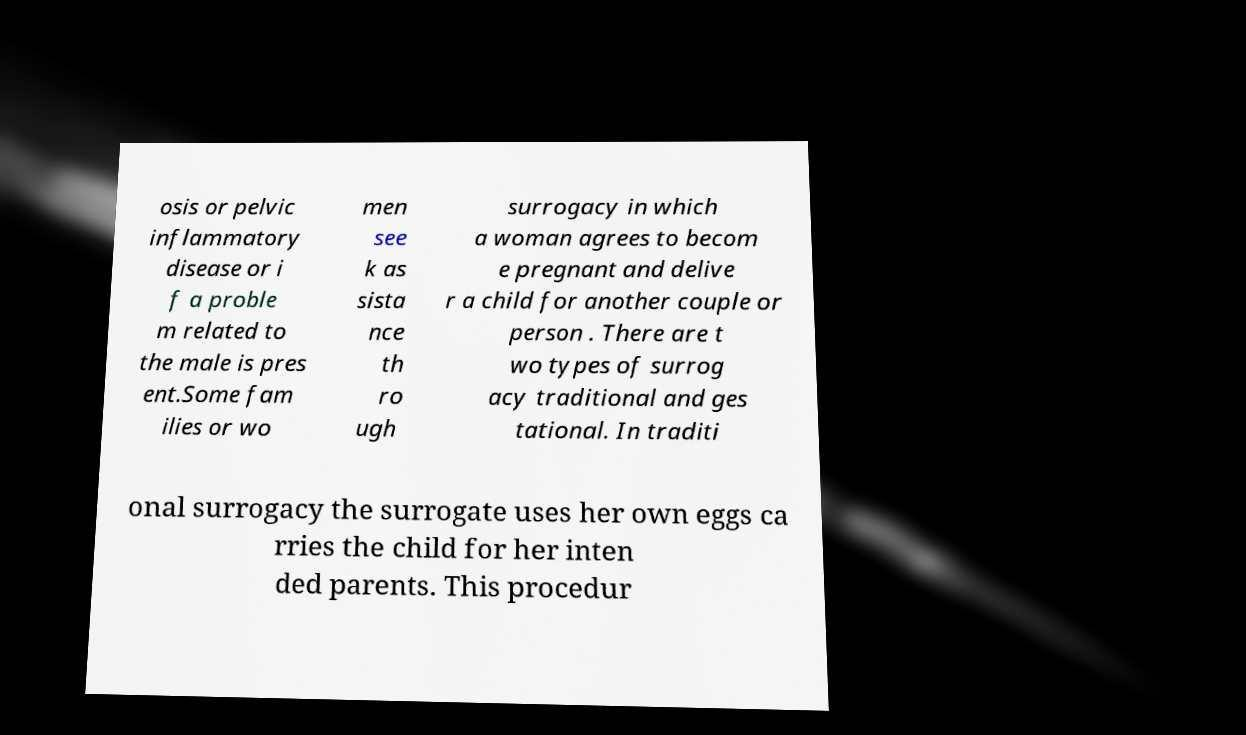There's text embedded in this image that I need extracted. Can you transcribe it verbatim? osis or pelvic inflammatory disease or i f a proble m related to the male is pres ent.Some fam ilies or wo men see k as sista nce th ro ugh surrogacy in which a woman agrees to becom e pregnant and delive r a child for another couple or person . There are t wo types of surrog acy traditional and ges tational. In traditi onal surrogacy the surrogate uses her own eggs ca rries the child for her inten ded parents. This procedur 